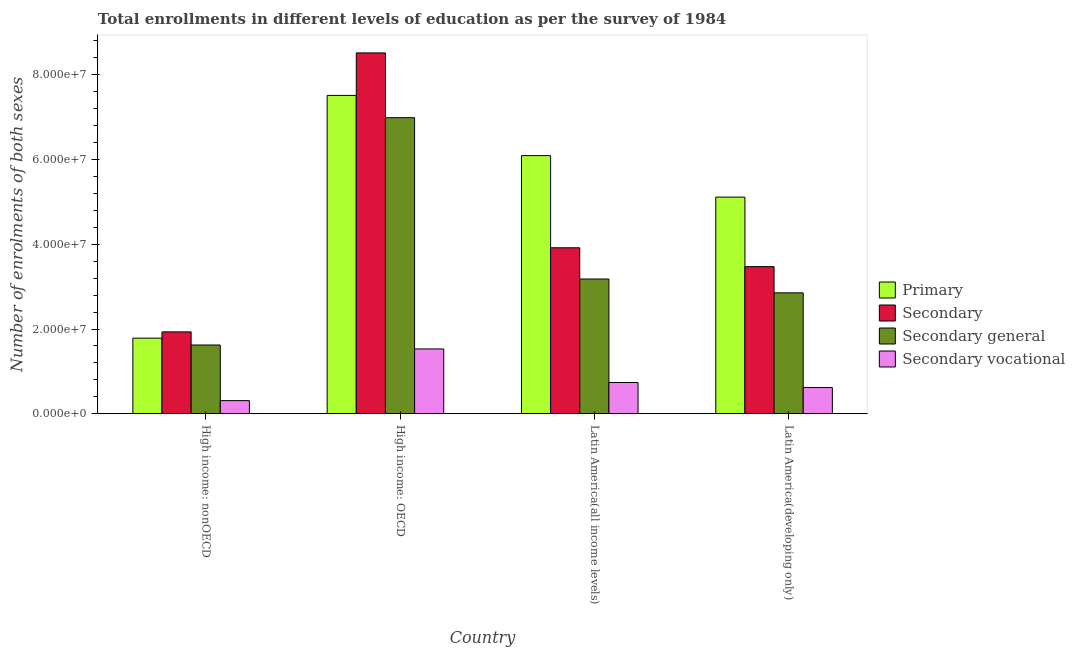How many groups of bars are there?
Give a very brief answer. 4. Are the number of bars per tick equal to the number of legend labels?
Keep it short and to the point. Yes. Are the number of bars on each tick of the X-axis equal?
Make the answer very short. Yes. What is the label of the 3rd group of bars from the left?
Your response must be concise. Latin America(all income levels). What is the number of enrolments in secondary education in Latin America(developing only)?
Your answer should be compact. 3.47e+07. Across all countries, what is the maximum number of enrolments in secondary vocational education?
Give a very brief answer. 1.53e+07. Across all countries, what is the minimum number of enrolments in secondary general education?
Provide a succinct answer. 1.62e+07. In which country was the number of enrolments in secondary general education maximum?
Give a very brief answer. High income: OECD. In which country was the number of enrolments in primary education minimum?
Offer a very short reply. High income: nonOECD. What is the total number of enrolments in secondary vocational education in the graph?
Offer a very short reply. 3.20e+07. What is the difference between the number of enrolments in secondary education in High income: OECD and that in Latin America(all income levels)?
Your answer should be compact. 4.60e+07. What is the difference between the number of enrolments in secondary general education in Latin America(all income levels) and the number of enrolments in secondary vocational education in High income: OECD?
Offer a very short reply. 1.65e+07. What is the average number of enrolments in primary education per country?
Make the answer very short. 5.13e+07. What is the difference between the number of enrolments in secondary vocational education and number of enrolments in primary education in High income: nonOECD?
Ensure brevity in your answer.  -1.47e+07. What is the ratio of the number of enrolments in secondary general education in High income: nonOECD to that in Latin America(all income levels)?
Provide a succinct answer. 0.51. Is the difference between the number of enrolments in secondary vocational education in Latin America(all income levels) and Latin America(developing only) greater than the difference between the number of enrolments in primary education in Latin America(all income levels) and Latin America(developing only)?
Offer a terse response. No. What is the difference between the highest and the second highest number of enrolments in primary education?
Provide a succinct answer. 1.42e+07. What is the difference between the highest and the lowest number of enrolments in primary education?
Your response must be concise. 5.73e+07. Is the sum of the number of enrolments in primary education in High income: nonOECD and Latin America(all income levels) greater than the maximum number of enrolments in secondary vocational education across all countries?
Your response must be concise. Yes. What does the 4th bar from the left in Latin America(all income levels) represents?
Offer a terse response. Secondary vocational. What does the 4th bar from the right in High income: nonOECD represents?
Provide a short and direct response. Primary. Is it the case that in every country, the sum of the number of enrolments in primary education and number of enrolments in secondary education is greater than the number of enrolments in secondary general education?
Provide a short and direct response. Yes. Are all the bars in the graph horizontal?
Your answer should be compact. No. How many countries are there in the graph?
Provide a short and direct response. 4. Are the values on the major ticks of Y-axis written in scientific E-notation?
Make the answer very short. Yes. Does the graph contain any zero values?
Your response must be concise. No. How are the legend labels stacked?
Keep it short and to the point. Vertical. What is the title of the graph?
Offer a very short reply. Total enrollments in different levels of education as per the survey of 1984. What is the label or title of the Y-axis?
Provide a short and direct response. Number of enrolments of both sexes. What is the Number of enrolments of both sexes in Primary in High income: nonOECD?
Your answer should be very brief. 1.78e+07. What is the Number of enrolments of both sexes of Secondary in High income: nonOECD?
Your answer should be compact. 1.93e+07. What is the Number of enrolments of both sexes of Secondary general in High income: nonOECD?
Your response must be concise. 1.62e+07. What is the Number of enrolments of both sexes of Secondary vocational in High income: nonOECD?
Your answer should be compact. 3.10e+06. What is the Number of enrolments of both sexes in Primary in High income: OECD?
Your response must be concise. 7.52e+07. What is the Number of enrolments of both sexes of Secondary in High income: OECD?
Your answer should be compact. 8.52e+07. What is the Number of enrolments of both sexes of Secondary general in High income: OECD?
Your answer should be very brief. 6.99e+07. What is the Number of enrolments of both sexes in Secondary vocational in High income: OECD?
Offer a very short reply. 1.53e+07. What is the Number of enrolments of both sexes in Primary in Latin America(all income levels)?
Your response must be concise. 6.09e+07. What is the Number of enrolments of both sexes in Secondary in Latin America(all income levels)?
Make the answer very short. 3.92e+07. What is the Number of enrolments of both sexes in Secondary general in Latin America(all income levels)?
Your response must be concise. 3.18e+07. What is the Number of enrolments of both sexes of Secondary vocational in Latin America(all income levels)?
Your response must be concise. 7.37e+06. What is the Number of enrolments of both sexes in Primary in Latin America(developing only)?
Make the answer very short. 5.11e+07. What is the Number of enrolments of both sexes of Secondary in Latin America(developing only)?
Give a very brief answer. 3.47e+07. What is the Number of enrolments of both sexes of Secondary general in Latin America(developing only)?
Provide a short and direct response. 2.85e+07. What is the Number of enrolments of both sexes of Secondary vocational in Latin America(developing only)?
Offer a terse response. 6.19e+06. Across all countries, what is the maximum Number of enrolments of both sexes in Primary?
Your answer should be very brief. 7.52e+07. Across all countries, what is the maximum Number of enrolments of both sexes of Secondary?
Make the answer very short. 8.52e+07. Across all countries, what is the maximum Number of enrolments of both sexes of Secondary general?
Provide a short and direct response. 6.99e+07. Across all countries, what is the maximum Number of enrolments of both sexes of Secondary vocational?
Your answer should be very brief. 1.53e+07. Across all countries, what is the minimum Number of enrolments of both sexes of Primary?
Provide a short and direct response. 1.78e+07. Across all countries, what is the minimum Number of enrolments of both sexes in Secondary?
Provide a succinct answer. 1.93e+07. Across all countries, what is the minimum Number of enrolments of both sexes of Secondary general?
Provide a succinct answer. 1.62e+07. Across all countries, what is the minimum Number of enrolments of both sexes in Secondary vocational?
Your answer should be very brief. 3.10e+06. What is the total Number of enrolments of both sexes in Primary in the graph?
Your answer should be very brief. 2.05e+08. What is the total Number of enrolments of both sexes of Secondary in the graph?
Offer a terse response. 1.78e+08. What is the total Number of enrolments of both sexes in Secondary general in the graph?
Keep it short and to the point. 1.46e+08. What is the total Number of enrolments of both sexes of Secondary vocational in the graph?
Keep it short and to the point. 3.20e+07. What is the difference between the Number of enrolments of both sexes of Primary in High income: nonOECD and that in High income: OECD?
Your response must be concise. -5.73e+07. What is the difference between the Number of enrolments of both sexes of Secondary in High income: nonOECD and that in High income: OECD?
Ensure brevity in your answer.  -6.59e+07. What is the difference between the Number of enrolments of both sexes in Secondary general in High income: nonOECD and that in High income: OECD?
Your answer should be compact. -5.37e+07. What is the difference between the Number of enrolments of both sexes in Secondary vocational in High income: nonOECD and that in High income: OECD?
Offer a terse response. -1.22e+07. What is the difference between the Number of enrolments of both sexes in Primary in High income: nonOECD and that in Latin America(all income levels)?
Make the answer very short. -4.31e+07. What is the difference between the Number of enrolments of both sexes of Secondary in High income: nonOECD and that in Latin America(all income levels)?
Keep it short and to the point. -1.99e+07. What is the difference between the Number of enrolments of both sexes in Secondary general in High income: nonOECD and that in Latin America(all income levels)?
Offer a terse response. -1.56e+07. What is the difference between the Number of enrolments of both sexes of Secondary vocational in High income: nonOECD and that in Latin America(all income levels)?
Ensure brevity in your answer.  -4.27e+06. What is the difference between the Number of enrolments of both sexes in Primary in High income: nonOECD and that in Latin America(developing only)?
Your response must be concise. -3.33e+07. What is the difference between the Number of enrolments of both sexes in Secondary in High income: nonOECD and that in Latin America(developing only)?
Offer a very short reply. -1.54e+07. What is the difference between the Number of enrolments of both sexes of Secondary general in High income: nonOECD and that in Latin America(developing only)?
Provide a succinct answer. -1.23e+07. What is the difference between the Number of enrolments of both sexes of Secondary vocational in High income: nonOECD and that in Latin America(developing only)?
Offer a very short reply. -3.09e+06. What is the difference between the Number of enrolments of both sexes of Primary in High income: OECD and that in Latin America(all income levels)?
Provide a short and direct response. 1.42e+07. What is the difference between the Number of enrolments of both sexes in Secondary in High income: OECD and that in Latin America(all income levels)?
Provide a short and direct response. 4.60e+07. What is the difference between the Number of enrolments of both sexes of Secondary general in High income: OECD and that in Latin America(all income levels)?
Offer a very short reply. 3.81e+07. What is the difference between the Number of enrolments of both sexes of Secondary vocational in High income: OECD and that in Latin America(all income levels)?
Make the answer very short. 7.92e+06. What is the difference between the Number of enrolments of both sexes in Primary in High income: OECD and that in Latin America(developing only)?
Ensure brevity in your answer.  2.40e+07. What is the difference between the Number of enrolments of both sexes of Secondary in High income: OECD and that in Latin America(developing only)?
Your response must be concise. 5.05e+07. What is the difference between the Number of enrolments of both sexes in Secondary general in High income: OECD and that in Latin America(developing only)?
Give a very brief answer. 4.14e+07. What is the difference between the Number of enrolments of both sexes of Secondary vocational in High income: OECD and that in Latin America(developing only)?
Provide a short and direct response. 9.11e+06. What is the difference between the Number of enrolments of both sexes in Primary in Latin America(all income levels) and that in Latin America(developing only)?
Ensure brevity in your answer.  9.79e+06. What is the difference between the Number of enrolments of both sexes of Secondary in Latin America(all income levels) and that in Latin America(developing only)?
Offer a very short reply. 4.45e+06. What is the difference between the Number of enrolments of both sexes of Secondary general in Latin America(all income levels) and that in Latin America(developing only)?
Offer a terse response. 3.27e+06. What is the difference between the Number of enrolments of both sexes of Secondary vocational in Latin America(all income levels) and that in Latin America(developing only)?
Provide a succinct answer. 1.18e+06. What is the difference between the Number of enrolments of both sexes of Primary in High income: nonOECD and the Number of enrolments of both sexes of Secondary in High income: OECD?
Give a very brief answer. -6.73e+07. What is the difference between the Number of enrolments of both sexes of Primary in High income: nonOECD and the Number of enrolments of both sexes of Secondary general in High income: OECD?
Make the answer very short. -5.20e+07. What is the difference between the Number of enrolments of both sexes in Primary in High income: nonOECD and the Number of enrolments of both sexes in Secondary vocational in High income: OECD?
Give a very brief answer. 2.55e+06. What is the difference between the Number of enrolments of both sexes of Secondary in High income: nonOECD and the Number of enrolments of both sexes of Secondary general in High income: OECD?
Offer a very short reply. -5.06e+07. What is the difference between the Number of enrolments of both sexes in Secondary in High income: nonOECD and the Number of enrolments of both sexes in Secondary vocational in High income: OECD?
Offer a terse response. 4.03e+06. What is the difference between the Number of enrolments of both sexes of Secondary general in High income: nonOECD and the Number of enrolments of both sexes of Secondary vocational in High income: OECD?
Make the answer very short. 9.31e+05. What is the difference between the Number of enrolments of both sexes in Primary in High income: nonOECD and the Number of enrolments of both sexes in Secondary in Latin America(all income levels)?
Your response must be concise. -2.13e+07. What is the difference between the Number of enrolments of both sexes of Primary in High income: nonOECD and the Number of enrolments of both sexes of Secondary general in Latin America(all income levels)?
Make the answer very short. -1.40e+07. What is the difference between the Number of enrolments of both sexes of Primary in High income: nonOECD and the Number of enrolments of both sexes of Secondary vocational in Latin America(all income levels)?
Make the answer very short. 1.05e+07. What is the difference between the Number of enrolments of both sexes of Secondary in High income: nonOECD and the Number of enrolments of both sexes of Secondary general in Latin America(all income levels)?
Provide a short and direct response. -1.25e+07. What is the difference between the Number of enrolments of both sexes of Secondary in High income: nonOECD and the Number of enrolments of both sexes of Secondary vocational in Latin America(all income levels)?
Your answer should be compact. 1.20e+07. What is the difference between the Number of enrolments of both sexes of Secondary general in High income: nonOECD and the Number of enrolments of both sexes of Secondary vocational in Latin America(all income levels)?
Offer a very short reply. 8.85e+06. What is the difference between the Number of enrolments of both sexes in Primary in High income: nonOECD and the Number of enrolments of both sexes in Secondary in Latin America(developing only)?
Provide a short and direct response. -1.69e+07. What is the difference between the Number of enrolments of both sexes in Primary in High income: nonOECD and the Number of enrolments of both sexes in Secondary general in Latin America(developing only)?
Provide a short and direct response. -1.07e+07. What is the difference between the Number of enrolments of both sexes in Primary in High income: nonOECD and the Number of enrolments of both sexes in Secondary vocational in Latin America(developing only)?
Ensure brevity in your answer.  1.17e+07. What is the difference between the Number of enrolments of both sexes in Secondary in High income: nonOECD and the Number of enrolments of both sexes in Secondary general in Latin America(developing only)?
Your answer should be very brief. -9.21e+06. What is the difference between the Number of enrolments of both sexes in Secondary in High income: nonOECD and the Number of enrolments of both sexes in Secondary vocational in Latin America(developing only)?
Keep it short and to the point. 1.31e+07. What is the difference between the Number of enrolments of both sexes in Secondary general in High income: nonOECD and the Number of enrolments of both sexes in Secondary vocational in Latin America(developing only)?
Offer a very short reply. 1.00e+07. What is the difference between the Number of enrolments of both sexes in Primary in High income: OECD and the Number of enrolments of both sexes in Secondary in Latin America(all income levels)?
Offer a terse response. 3.60e+07. What is the difference between the Number of enrolments of both sexes in Primary in High income: OECD and the Number of enrolments of both sexes in Secondary general in Latin America(all income levels)?
Offer a very short reply. 4.33e+07. What is the difference between the Number of enrolments of both sexes in Primary in High income: OECD and the Number of enrolments of both sexes in Secondary vocational in Latin America(all income levels)?
Make the answer very short. 6.78e+07. What is the difference between the Number of enrolments of both sexes of Secondary in High income: OECD and the Number of enrolments of both sexes of Secondary general in Latin America(all income levels)?
Offer a very short reply. 5.34e+07. What is the difference between the Number of enrolments of both sexes in Secondary in High income: OECD and the Number of enrolments of both sexes in Secondary vocational in Latin America(all income levels)?
Your answer should be compact. 7.78e+07. What is the difference between the Number of enrolments of both sexes of Secondary general in High income: OECD and the Number of enrolments of both sexes of Secondary vocational in Latin America(all income levels)?
Make the answer very short. 6.25e+07. What is the difference between the Number of enrolments of both sexes in Primary in High income: OECD and the Number of enrolments of both sexes in Secondary in Latin America(developing only)?
Offer a very short reply. 4.04e+07. What is the difference between the Number of enrolments of both sexes of Primary in High income: OECD and the Number of enrolments of both sexes of Secondary general in Latin America(developing only)?
Your answer should be very brief. 4.66e+07. What is the difference between the Number of enrolments of both sexes in Primary in High income: OECD and the Number of enrolments of both sexes in Secondary vocational in Latin America(developing only)?
Provide a succinct answer. 6.90e+07. What is the difference between the Number of enrolments of both sexes of Secondary in High income: OECD and the Number of enrolments of both sexes of Secondary general in Latin America(developing only)?
Your answer should be very brief. 5.66e+07. What is the difference between the Number of enrolments of both sexes in Secondary in High income: OECD and the Number of enrolments of both sexes in Secondary vocational in Latin America(developing only)?
Ensure brevity in your answer.  7.90e+07. What is the difference between the Number of enrolments of both sexes of Secondary general in High income: OECD and the Number of enrolments of both sexes of Secondary vocational in Latin America(developing only)?
Ensure brevity in your answer.  6.37e+07. What is the difference between the Number of enrolments of both sexes of Primary in Latin America(all income levels) and the Number of enrolments of both sexes of Secondary in Latin America(developing only)?
Keep it short and to the point. 2.62e+07. What is the difference between the Number of enrolments of both sexes of Primary in Latin America(all income levels) and the Number of enrolments of both sexes of Secondary general in Latin America(developing only)?
Provide a short and direct response. 3.24e+07. What is the difference between the Number of enrolments of both sexes of Primary in Latin America(all income levels) and the Number of enrolments of both sexes of Secondary vocational in Latin America(developing only)?
Ensure brevity in your answer.  5.48e+07. What is the difference between the Number of enrolments of both sexes of Secondary in Latin America(all income levels) and the Number of enrolments of both sexes of Secondary general in Latin America(developing only)?
Your answer should be compact. 1.06e+07. What is the difference between the Number of enrolments of both sexes of Secondary in Latin America(all income levels) and the Number of enrolments of both sexes of Secondary vocational in Latin America(developing only)?
Provide a succinct answer. 3.30e+07. What is the difference between the Number of enrolments of both sexes in Secondary general in Latin America(all income levels) and the Number of enrolments of both sexes in Secondary vocational in Latin America(developing only)?
Your response must be concise. 2.56e+07. What is the average Number of enrolments of both sexes in Primary per country?
Keep it short and to the point. 5.13e+07. What is the average Number of enrolments of both sexes in Secondary per country?
Give a very brief answer. 4.46e+07. What is the average Number of enrolments of both sexes in Secondary general per country?
Provide a short and direct response. 3.66e+07. What is the average Number of enrolments of both sexes of Secondary vocational per country?
Make the answer very short. 7.99e+06. What is the difference between the Number of enrolments of both sexes of Primary and Number of enrolments of both sexes of Secondary in High income: nonOECD?
Ensure brevity in your answer.  -1.48e+06. What is the difference between the Number of enrolments of both sexes in Primary and Number of enrolments of both sexes in Secondary general in High income: nonOECD?
Your answer should be very brief. 1.62e+06. What is the difference between the Number of enrolments of both sexes of Primary and Number of enrolments of both sexes of Secondary vocational in High income: nonOECD?
Offer a terse response. 1.47e+07. What is the difference between the Number of enrolments of both sexes in Secondary and Number of enrolments of both sexes in Secondary general in High income: nonOECD?
Provide a succinct answer. 3.10e+06. What is the difference between the Number of enrolments of both sexes in Secondary and Number of enrolments of both sexes in Secondary vocational in High income: nonOECD?
Your answer should be very brief. 1.62e+07. What is the difference between the Number of enrolments of both sexes in Secondary general and Number of enrolments of both sexes in Secondary vocational in High income: nonOECD?
Provide a short and direct response. 1.31e+07. What is the difference between the Number of enrolments of both sexes in Primary and Number of enrolments of both sexes in Secondary in High income: OECD?
Give a very brief answer. -1.00e+07. What is the difference between the Number of enrolments of both sexes in Primary and Number of enrolments of both sexes in Secondary general in High income: OECD?
Provide a short and direct response. 5.27e+06. What is the difference between the Number of enrolments of both sexes in Primary and Number of enrolments of both sexes in Secondary vocational in High income: OECD?
Provide a succinct answer. 5.99e+07. What is the difference between the Number of enrolments of both sexes of Secondary and Number of enrolments of both sexes of Secondary general in High income: OECD?
Your answer should be compact. 1.53e+07. What is the difference between the Number of enrolments of both sexes in Secondary and Number of enrolments of both sexes in Secondary vocational in High income: OECD?
Provide a short and direct response. 6.99e+07. What is the difference between the Number of enrolments of both sexes in Secondary general and Number of enrolments of both sexes in Secondary vocational in High income: OECD?
Give a very brief answer. 5.46e+07. What is the difference between the Number of enrolments of both sexes in Primary and Number of enrolments of both sexes in Secondary in Latin America(all income levels)?
Provide a succinct answer. 2.18e+07. What is the difference between the Number of enrolments of both sexes of Primary and Number of enrolments of both sexes of Secondary general in Latin America(all income levels)?
Offer a terse response. 2.91e+07. What is the difference between the Number of enrolments of both sexes of Primary and Number of enrolments of both sexes of Secondary vocational in Latin America(all income levels)?
Offer a terse response. 5.36e+07. What is the difference between the Number of enrolments of both sexes in Secondary and Number of enrolments of both sexes in Secondary general in Latin America(all income levels)?
Offer a very short reply. 7.37e+06. What is the difference between the Number of enrolments of both sexes in Secondary and Number of enrolments of both sexes in Secondary vocational in Latin America(all income levels)?
Give a very brief answer. 3.18e+07. What is the difference between the Number of enrolments of both sexes of Secondary general and Number of enrolments of both sexes of Secondary vocational in Latin America(all income levels)?
Your answer should be very brief. 2.44e+07. What is the difference between the Number of enrolments of both sexes in Primary and Number of enrolments of both sexes in Secondary in Latin America(developing only)?
Provide a short and direct response. 1.64e+07. What is the difference between the Number of enrolments of both sexes of Primary and Number of enrolments of both sexes of Secondary general in Latin America(developing only)?
Your answer should be compact. 2.26e+07. What is the difference between the Number of enrolments of both sexes of Primary and Number of enrolments of both sexes of Secondary vocational in Latin America(developing only)?
Ensure brevity in your answer.  4.50e+07. What is the difference between the Number of enrolments of both sexes of Secondary and Number of enrolments of both sexes of Secondary general in Latin America(developing only)?
Your answer should be compact. 6.19e+06. What is the difference between the Number of enrolments of both sexes of Secondary and Number of enrolments of both sexes of Secondary vocational in Latin America(developing only)?
Your response must be concise. 2.85e+07. What is the difference between the Number of enrolments of both sexes in Secondary general and Number of enrolments of both sexes in Secondary vocational in Latin America(developing only)?
Your answer should be very brief. 2.23e+07. What is the ratio of the Number of enrolments of both sexes in Primary in High income: nonOECD to that in High income: OECD?
Give a very brief answer. 0.24. What is the ratio of the Number of enrolments of both sexes of Secondary in High income: nonOECD to that in High income: OECD?
Make the answer very short. 0.23. What is the ratio of the Number of enrolments of both sexes of Secondary general in High income: nonOECD to that in High income: OECD?
Offer a very short reply. 0.23. What is the ratio of the Number of enrolments of both sexes in Secondary vocational in High income: nonOECD to that in High income: OECD?
Ensure brevity in your answer.  0.2. What is the ratio of the Number of enrolments of both sexes of Primary in High income: nonOECD to that in Latin America(all income levels)?
Make the answer very short. 0.29. What is the ratio of the Number of enrolments of both sexes of Secondary in High income: nonOECD to that in Latin America(all income levels)?
Keep it short and to the point. 0.49. What is the ratio of the Number of enrolments of both sexes in Secondary general in High income: nonOECD to that in Latin America(all income levels)?
Your response must be concise. 0.51. What is the ratio of the Number of enrolments of both sexes of Secondary vocational in High income: nonOECD to that in Latin America(all income levels)?
Ensure brevity in your answer.  0.42. What is the ratio of the Number of enrolments of both sexes in Primary in High income: nonOECD to that in Latin America(developing only)?
Offer a very short reply. 0.35. What is the ratio of the Number of enrolments of both sexes of Secondary in High income: nonOECD to that in Latin America(developing only)?
Provide a short and direct response. 0.56. What is the ratio of the Number of enrolments of both sexes in Secondary general in High income: nonOECD to that in Latin America(developing only)?
Your answer should be very brief. 0.57. What is the ratio of the Number of enrolments of both sexes of Secondary vocational in High income: nonOECD to that in Latin America(developing only)?
Offer a very short reply. 0.5. What is the ratio of the Number of enrolments of both sexes in Primary in High income: OECD to that in Latin America(all income levels)?
Your response must be concise. 1.23. What is the ratio of the Number of enrolments of both sexes in Secondary in High income: OECD to that in Latin America(all income levels)?
Offer a very short reply. 2.17. What is the ratio of the Number of enrolments of both sexes in Secondary general in High income: OECD to that in Latin America(all income levels)?
Provide a succinct answer. 2.2. What is the ratio of the Number of enrolments of both sexes in Secondary vocational in High income: OECD to that in Latin America(all income levels)?
Offer a terse response. 2.07. What is the ratio of the Number of enrolments of both sexes of Primary in High income: OECD to that in Latin America(developing only)?
Your answer should be very brief. 1.47. What is the ratio of the Number of enrolments of both sexes in Secondary in High income: OECD to that in Latin America(developing only)?
Offer a very short reply. 2.45. What is the ratio of the Number of enrolments of both sexes in Secondary general in High income: OECD to that in Latin America(developing only)?
Provide a succinct answer. 2.45. What is the ratio of the Number of enrolments of both sexes of Secondary vocational in High income: OECD to that in Latin America(developing only)?
Offer a terse response. 2.47. What is the ratio of the Number of enrolments of both sexes in Primary in Latin America(all income levels) to that in Latin America(developing only)?
Keep it short and to the point. 1.19. What is the ratio of the Number of enrolments of both sexes in Secondary in Latin America(all income levels) to that in Latin America(developing only)?
Make the answer very short. 1.13. What is the ratio of the Number of enrolments of both sexes of Secondary general in Latin America(all income levels) to that in Latin America(developing only)?
Offer a very short reply. 1.11. What is the ratio of the Number of enrolments of both sexes of Secondary vocational in Latin America(all income levels) to that in Latin America(developing only)?
Provide a short and direct response. 1.19. What is the difference between the highest and the second highest Number of enrolments of both sexes in Primary?
Provide a short and direct response. 1.42e+07. What is the difference between the highest and the second highest Number of enrolments of both sexes in Secondary?
Offer a very short reply. 4.60e+07. What is the difference between the highest and the second highest Number of enrolments of both sexes in Secondary general?
Your answer should be very brief. 3.81e+07. What is the difference between the highest and the second highest Number of enrolments of both sexes of Secondary vocational?
Your answer should be compact. 7.92e+06. What is the difference between the highest and the lowest Number of enrolments of both sexes in Primary?
Ensure brevity in your answer.  5.73e+07. What is the difference between the highest and the lowest Number of enrolments of both sexes of Secondary?
Ensure brevity in your answer.  6.59e+07. What is the difference between the highest and the lowest Number of enrolments of both sexes in Secondary general?
Provide a short and direct response. 5.37e+07. What is the difference between the highest and the lowest Number of enrolments of both sexes in Secondary vocational?
Provide a short and direct response. 1.22e+07. 